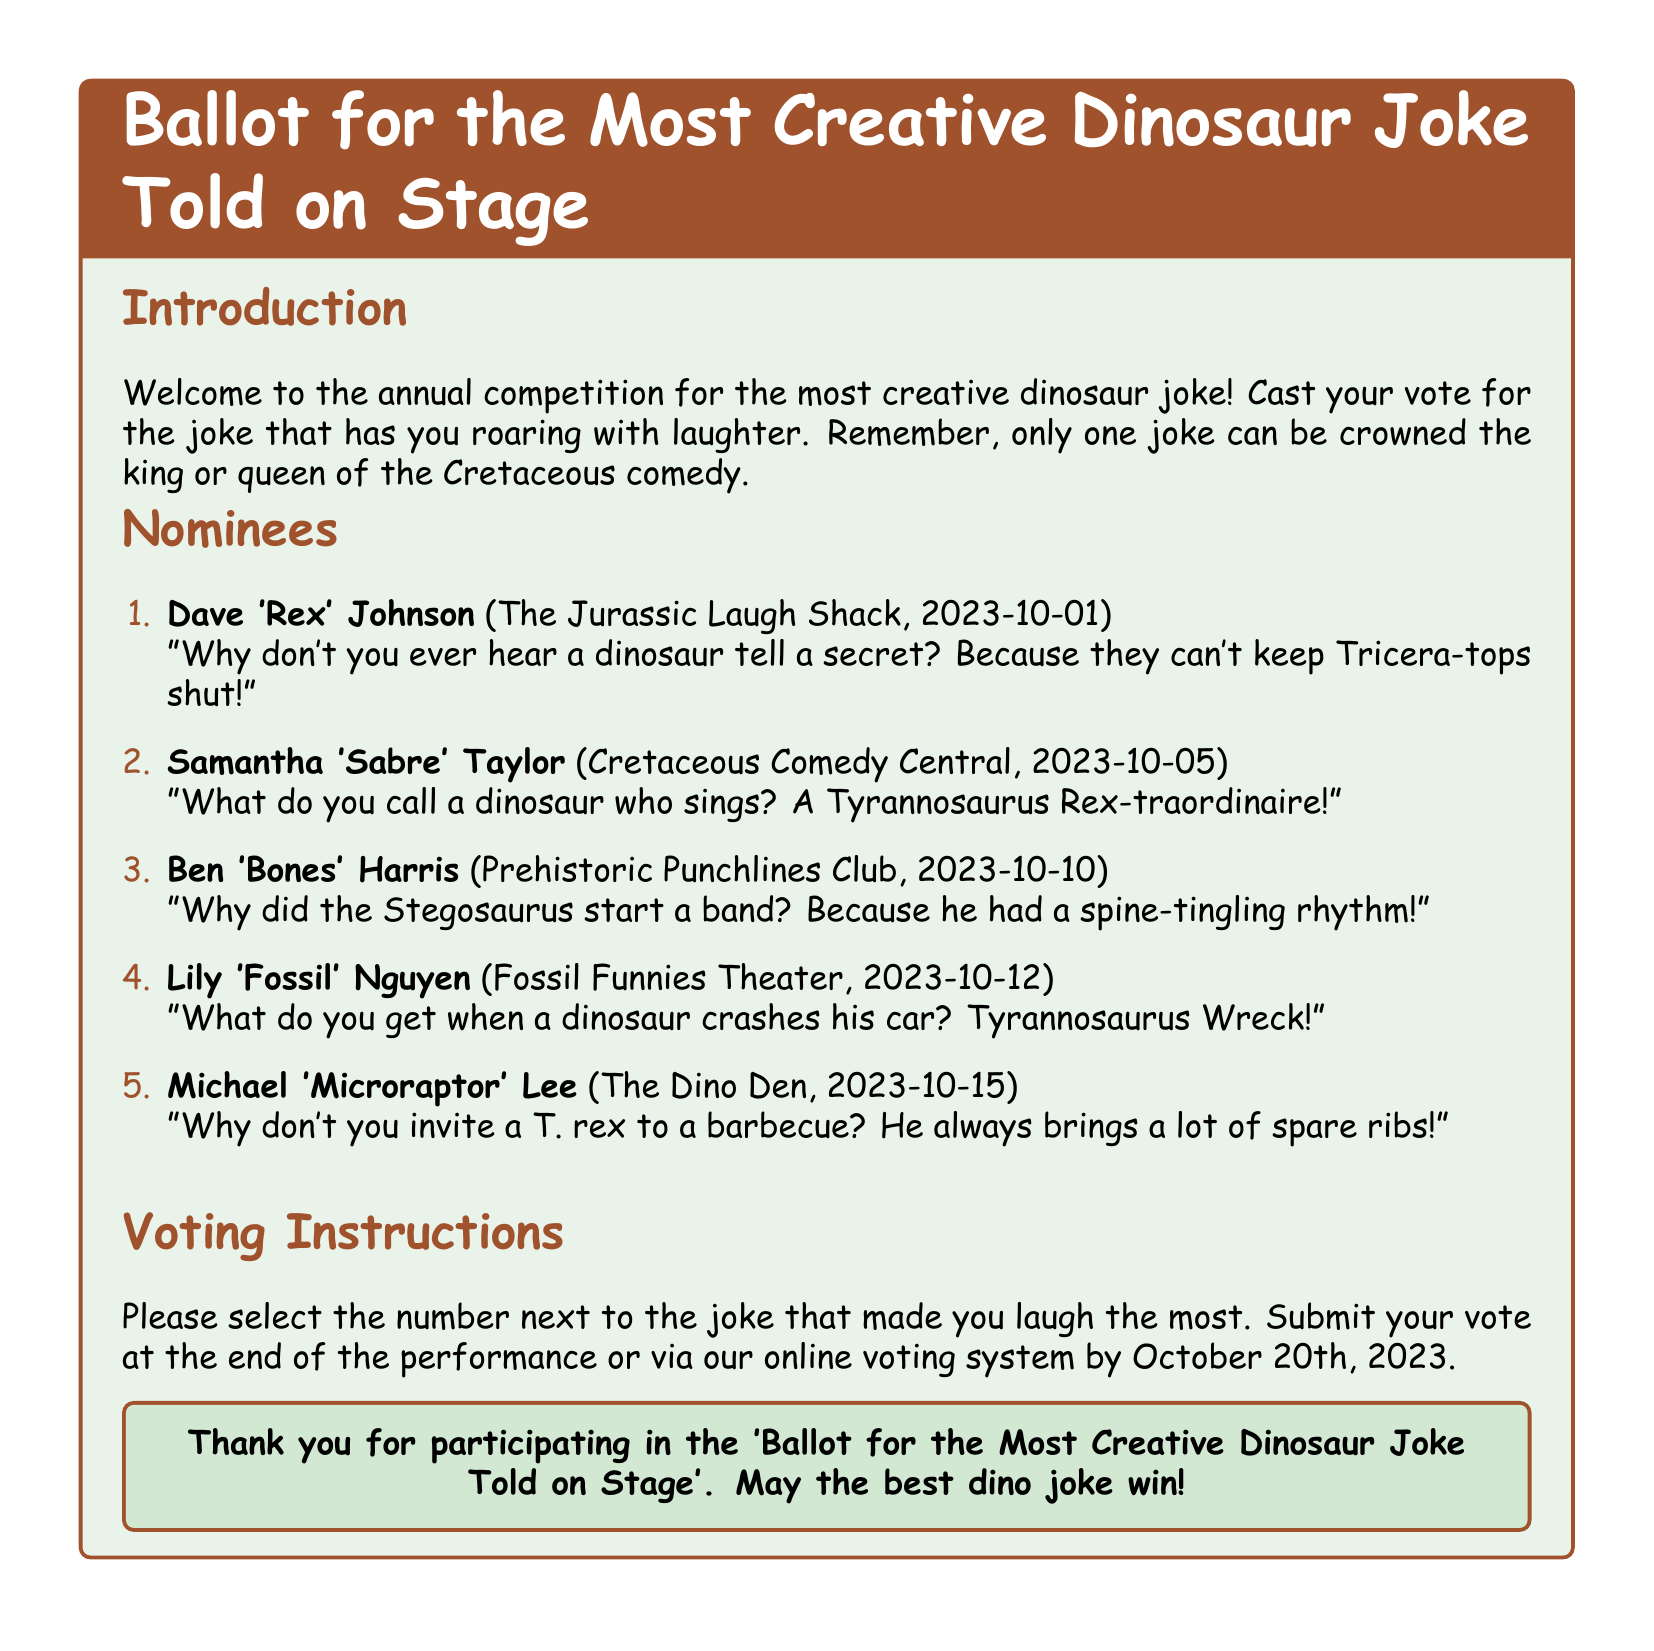What is the title of the document? The title is presented at the top and defines the purpose of the document, which is for voting on jokes.
Answer: Ballot for the Most Creative Dinosaur Joke Told on Stage How many nominees are listed? The document includes a numbered list of nominees for the joke competition.
Answer: 5 Who performed at the Jurassic Laugh Shack? The document specifies the performer and their venue, along with the date of their performance.
Answer: Dave 'Rex' Johnson What is the date for submitting votes? The voting instructions indicate a deadline for when votes can be submitted.
Answer: October 20th, 2023 Which joke features a car crash? The nominees all have distinct jokes, and this one is specifically about a car incident involving a dinosaur.
Answer: What do you get when a dinosaur crashes his car? Tyrannosaurus Wreck! What type of performance is this ballot for? The document indicates the nature of the competition and what is being judged.
Answer: Comedy How is the winner of the ballot determined? The document implies a voting process to choose the best joke among the nominees.
Answer: Voting What color is the text for the sections in the document? The document uses a specific color for the section titles to enhance the visual presentation.
Answer: Fossil brown 